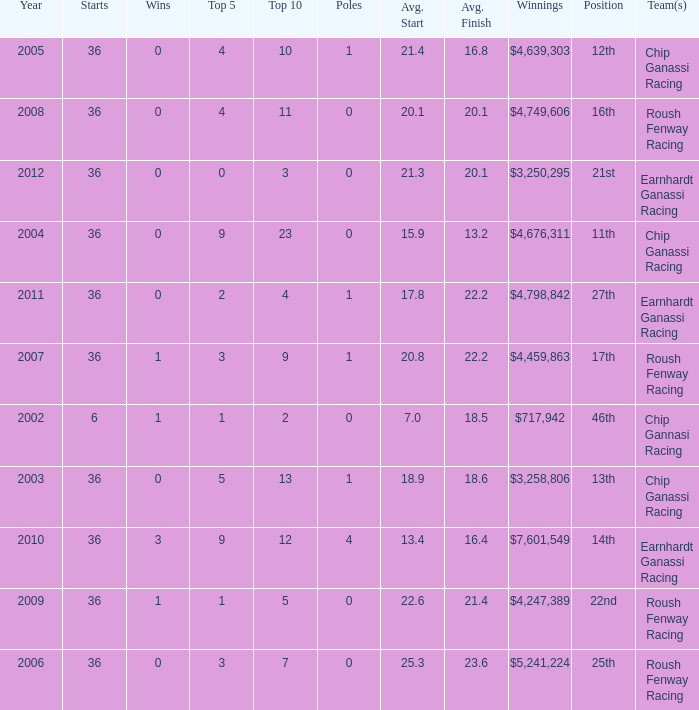Identify the stars that are in the 16th position. 36.0. 